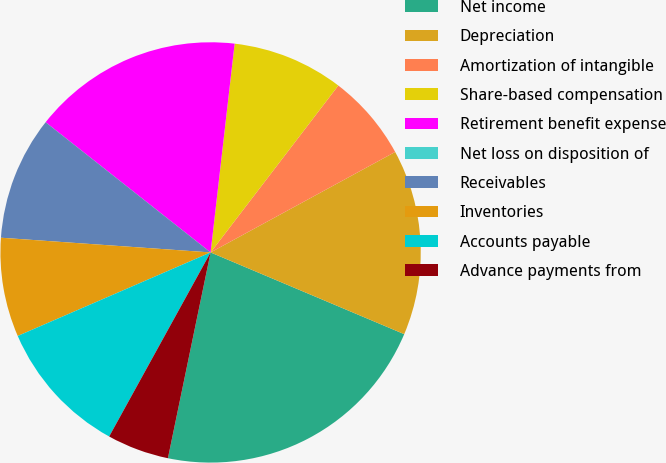Convert chart to OTSL. <chart><loc_0><loc_0><loc_500><loc_500><pie_chart><fcel>Net income<fcel>Depreciation<fcel>Amortization of intangible<fcel>Share-based compensation<fcel>Retirement benefit expense<fcel>Net loss on disposition of<fcel>Receivables<fcel>Inventories<fcel>Accounts payable<fcel>Advance payments from<nl><fcel>21.9%<fcel>14.29%<fcel>6.67%<fcel>8.57%<fcel>16.19%<fcel>0.0%<fcel>9.52%<fcel>7.62%<fcel>10.48%<fcel>4.76%<nl></chart> 